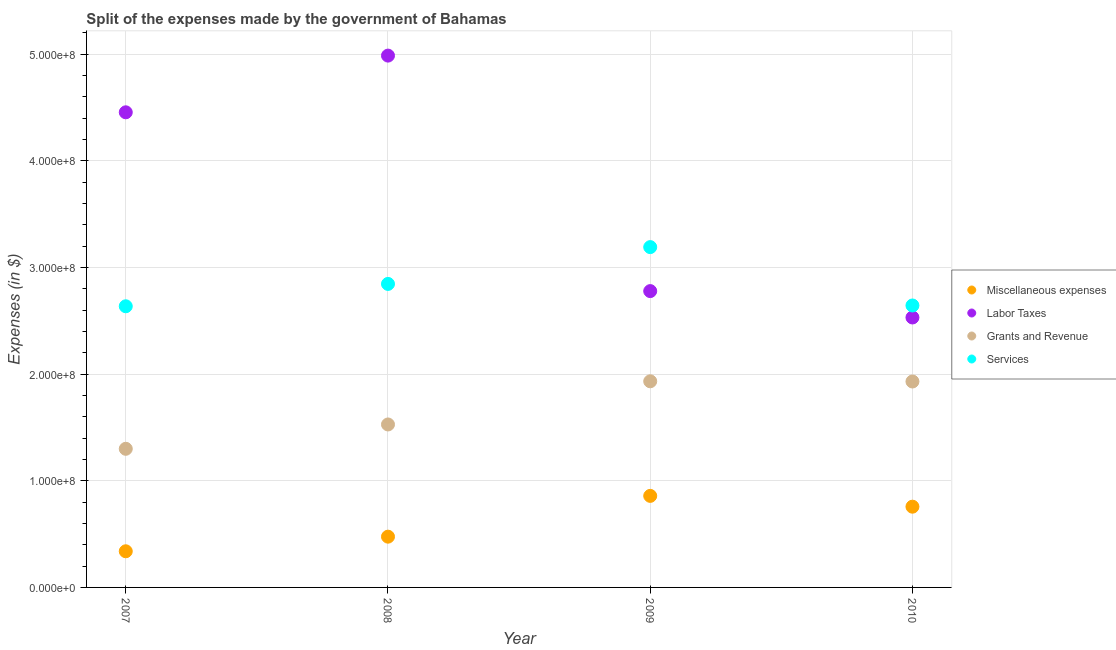What is the amount spent on labor taxes in 2008?
Provide a short and direct response. 4.99e+08. Across all years, what is the maximum amount spent on labor taxes?
Provide a short and direct response. 4.99e+08. Across all years, what is the minimum amount spent on miscellaneous expenses?
Keep it short and to the point. 3.39e+07. What is the total amount spent on grants and revenue in the graph?
Your answer should be compact. 6.69e+08. What is the difference between the amount spent on grants and revenue in 2007 and that in 2008?
Offer a terse response. -2.28e+07. What is the difference between the amount spent on services in 2010 and the amount spent on grants and revenue in 2009?
Keep it short and to the point. 7.11e+07. What is the average amount spent on services per year?
Offer a very short reply. 2.83e+08. In the year 2009, what is the difference between the amount spent on services and amount spent on grants and revenue?
Provide a succinct answer. 1.26e+08. In how many years, is the amount spent on miscellaneous expenses greater than 160000000 $?
Make the answer very short. 0. What is the ratio of the amount spent on labor taxes in 2007 to that in 2009?
Provide a short and direct response. 1.6. Is the amount spent on miscellaneous expenses in 2007 less than that in 2008?
Your answer should be very brief. Yes. Is the difference between the amount spent on services in 2009 and 2010 greater than the difference between the amount spent on miscellaneous expenses in 2009 and 2010?
Ensure brevity in your answer.  Yes. What is the difference between the highest and the second highest amount spent on services?
Provide a succinct answer. 3.45e+07. What is the difference between the highest and the lowest amount spent on services?
Make the answer very short. 5.55e+07. Is the sum of the amount spent on grants and revenue in 2007 and 2009 greater than the maximum amount spent on labor taxes across all years?
Ensure brevity in your answer.  No. Is it the case that in every year, the sum of the amount spent on services and amount spent on miscellaneous expenses is greater than the sum of amount spent on grants and revenue and amount spent on labor taxes?
Your response must be concise. Yes. Is it the case that in every year, the sum of the amount spent on miscellaneous expenses and amount spent on labor taxes is greater than the amount spent on grants and revenue?
Offer a very short reply. Yes. Does the amount spent on labor taxes monotonically increase over the years?
Ensure brevity in your answer.  No. Is the amount spent on services strictly greater than the amount spent on miscellaneous expenses over the years?
Keep it short and to the point. Yes. What is the difference between two consecutive major ticks on the Y-axis?
Make the answer very short. 1.00e+08. Does the graph contain any zero values?
Your response must be concise. No. Where does the legend appear in the graph?
Give a very brief answer. Center right. How are the legend labels stacked?
Your answer should be very brief. Vertical. What is the title of the graph?
Give a very brief answer. Split of the expenses made by the government of Bahamas. Does "Overall level" appear as one of the legend labels in the graph?
Offer a terse response. No. What is the label or title of the X-axis?
Your response must be concise. Year. What is the label or title of the Y-axis?
Provide a short and direct response. Expenses (in $). What is the Expenses (in $) of Miscellaneous expenses in 2007?
Provide a short and direct response. 3.39e+07. What is the Expenses (in $) of Labor Taxes in 2007?
Your answer should be compact. 4.46e+08. What is the Expenses (in $) of Grants and Revenue in 2007?
Give a very brief answer. 1.30e+08. What is the Expenses (in $) in Services in 2007?
Give a very brief answer. 2.64e+08. What is the Expenses (in $) of Miscellaneous expenses in 2008?
Your answer should be compact. 4.76e+07. What is the Expenses (in $) of Labor Taxes in 2008?
Keep it short and to the point. 4.99e+08. What is the Expenses (in $) in Grants and Revenue in 2008?
Your answer should be compact. 1.53e+08. What is the Expenses (in $) of Services in 2008?
Offer a terse response. 2.85e+08. What is the Expenses (in $) in Miscellaneous expenses in 2009?
Provide a short and direct response. 8.58e+07. What is the Expenses (in $) in Labor Taxes in 2009?
Offer a terse response. 2.78e+08. What is the Expenses (in $) in Grants and Revenue in 2009?
Keep it short and to the point. 1.93e+08. What is the Expenses (in $) in Services in 2009?
Ensure brevity in your answer.  3.19e+08. What is the Expenses (in $) of Miscellaneous expenses in 2010?
Make the answer very short. 7.57e+07. What is the Expenses (in $) of Labor Taxes in 2010?
Provide a succinct answer. 2.53e+08. What is the Expenses (in $) in Grants and Revenue in 2010?
Give a very brief answer. 1.93e+08. What is the Expenses (in $) of Services in 2010?
Offer a terse response. 2.64e+08. Across all years, what is the maximum Expenses (in $) in Miscellaneous expenses?
Make the answer very short. 8.58e+07. Across all years, what is the maximum Expenses (in $) in Labor Taxes?
Offer a terse response. 4.99e+08. Across all years, what is the maximum Expenses (in $) of Grants and Revenue?
Your response must be concise. 1.93e+08. Across all years, what is the maximum Expenses (in $) in Services?
Your answer should be very brief. 3.19e+08. Across all years, what is the minimum Expenses (in $) of Miscellaneous expenses?
Offer a terse response. 3.39e+07. Across all years, what is the minimum Expenses (in $) in Labor Taxes?
Provide a succinct answer. 2.53e+08. Across all years, what is the minimum Expenses (in $) of Grants and Revenue?
Keep it short and to the point. 1.30e+08. Across all years, what is the minimum Expenses (in $) of Services?
Keep it short and to the point. 2.64e+08. What is the total Expenses (in $) in Miscellaneous expenses in the graph?
Provide a short and direct response. 2.43e+08. What is the total Expenses (in $) in Labor Taxes in the graph?
Offer a very short reply. 1.48e+09. What is the total Expenses (in $) in Grants and Revenue in the graph?
Provide a succinct answer. 6.69e+08. What is the total Expenses (in $) in Services in the graph?
Your answer should be very brief. 1.13e+09. What is the difference between the Expenses (in $) in Miscellaneous expenses in 2007 and that in 2008?
Give a very brief answer. -1.37e+07. What is the difference between the Expenses (in $) of Labor Taxes in 2007 and that in 2008?
Your answer should be very brief. -5.32e+07. What is the difference between the Expenses (in $) in Grants and Revenue in 2007 and that in 2008?
Your answer should be very brief. -2.28e+07. What is the difference between the Expenses (in $) of Services in 2007 and that in 2008?
Your answer should be very brief. -2.10e+07. What is the difference between the Expenses (in $) in Miscellaneous expenses in 2007 and that in 2009?
Make the answer very short. -5.19e+07. What is the difference between the Expenses (in $) of Labor Taxes in 2007 and that in 2009?
Offer a terse response. 1.68e+08. What is the difference between the Expenses (in $) in Grants and Revenue in 2007 and that in 2009?
Your response must be concise. -6.33e+07. What is the difference between the Expenses (in $) of Services in 2007 and that in 2009?
Provide a succinct answer. -5.55e+07. What is the difference between the Expenses (in $) in Miscellaneous expenses in 2007 and that in 2010?
Offer a terse response. -4.18e+07. What is the difference between the Expenses (in $) in Labor Taxes in 2007 and that in 2010?
Provide a short and direct response. 1.92e+08. What is the difference between the Expenses (in $) in Grants and Revenue in 2007 and that in 2010?
Provide a succinct answer. -6.31e+07. What is the difference between the Expenses (in $) of Services in 2007 and that in 2010?
Ensure brevity in your answer.  -7.35e+05. What is the difference between the Expenses (in $) of Miscellaneous expenses in 2008 and that in 2009?
Make the answer very short. -3.82e+07. What is the difference between the Expenses (in $) in Labor Taxes in 2008 and that in 2009?
Provide a succinct answer. 2.21e+08. What is the difference between the Expenses (in $) in Grants and Revenue in 2008 and that in 2009?
Keep it short and to the point. -4.05e+07. What is the difference between the Expenses (in $) in Services in 2008 and that in 2009?
Offer a very short reply. -3.45e+07. What is the difference between the Expenses (in $) of Miscellaneous expenses in 2008 and that in 2010?
Your answer should be compact. -2.81e+07. What is the difference between the Expenses (in $) in Labor Taxes in 2008 and that in 2010?
Offer a terse response. 2.46e+08. What is the difference between the Expenses (in $) of Grants and Revenue in 2008 and that in 2010?
Provide a short and direct response. -4.03e+07. What is the difference between the Expenses (in $) in Services in 2008 and that in 2010?
Give a very brief answer. 2.02e+07. What is the difference between the Expenses (in $) in Miscellaneous expenses in 2009 and that in 2010?
Provide a short and direct response. 1.01e+07. What is the difference between the Expenses (in $) of Labor Taxes in 2009 and that in 2010?
Offer a very short reply. 2.47e+07. What is the difference between the Expenses (in $) of Grants and Revenue in 2009 and that in 2010?
Offer a very short reply. 1.93e+05. What is the difference between the Expenses (in $) in Services in 2009 and that in 2010?
Your answer should be compact. 5.47e+07. What is the difference between the Expenses (in $) in Miscellaneous expenses in 2007 and the Expenses (in $) in Labor Taxes in 2008?
Offer a very short reply. -4.65e+08. What is the difference between the Expenses (in $) of Miscellaneous expenses in 2007 and the Expenses (in $) of Grants and Revenue in 2008?
Offer a terse response. -1.19e+08. What is the difference between the Expenses (in $) in Miscellaneous expenses in 2007 and the Expenses (in $) in Services in 2008?
Ensure brevity in your answer.  -2.51e+08. What is the difference between the Expenses (in $) in Labor Taxes in 2007 and the Expenses (in $) in Grants and Revenue in 2008?
Your answer should be very brief. 2.93e+08. What is the difference between the Expenses (in $) of Labor Taxes in 2007 and the Expenses (in $) of Services in 2008?
Offer a very short reply. 1.61e+08. What is the difference between the Expenses (in $) in Grants and Revenue in 2007 and the Expenses (in $) in Services in 2008?
Give a very brief answer. -1.55e+08. What is the difference between the Expenses (in $) of Miscellaneous expenses in 2007 and the Expenses (in $) of Labor Taxes in 2009?
Offer a terse response. -2.44e+08. What is the difference between the Expenses (in $) of Miscellaneous expenses in 2007 and the Expenses (in $) of Grants and Revenue in 2009?
Offer a terse response. -1.59e+08. What is the difference between the Expenses (in $) in Miscellaneous expenses in 2007 and the Expenses (in $) in Services in 2009?
Give a very brief answer. -2.85e+08. What is the difference between the Expenses (in $) of Labor Taxes in 2007 and the Expenses (in $) of Grants and Revenue in 2009?
Provide a short and direct response. 2.52e+08. What is the difference between the Expenses (in $) of Labor Taxes in 2007 and the Expenses (in $) of Services in 2009?
Make the answer very short. 1.26e+08. What is the difference between the Expenses (in $) in Grants and Revenue in 2007 and the Expenses (in $) in Services in 2009?
Keep it short and to the point. -1.89e+08. What is the difference between the Expenses (in $) of Miscellaneous expenses in 2007 and the Expenses (in $) of Labor Taxes in 2010?
Provide a short and direct response. -2.19e+08. What is the difference between the Expenses (in $) in Miscellaneous expenses in 2007 and the Expenses (in $) in Grants and Revenue in 2010?
Offer a terse response. -1.59e+08. What is the difference between the Expenses (in $) of Miscellaneous expenses in 2007 and the Expenses (in $) of Services in 2010?
Your response must be concise. -2.30e+08. What is the difference between the Expenses (in $) of Labor Taxes in 2007 and the Expenses (in $) of Grants and Revenue in 2010?
Make the answer very short. 2.52e+08. What is the difference between the Expenses (in $) of Labor Taxes in 2007 and the Expenses (in $) of Services in 2010?
Your answer should be compact. 1.81e+08. What is the difference between the Expenses (in $) in Grants and Revenue in 2007 and the Expenses (in $) in Services in 2010?
Your answer should be compact. -1.34e+08. What is the difference between the Expenses (in $) of Miscellaneous expenses in 2008 and the Expenses (in $) of Labor Taxes in 2009?
Keep it short and to the point. -2.30e+08. What is the difference between the Expenses (in $) of Miscellaneous expenses in 2008 and the Expenses (in $) of Grants and Revenue in 2009?
Make the answer very short. -1.46e+08. What is the difference between the Expenses (in $) of Miscellaneous expenses in 2008 and the Expenses (in $) of Services in 2009?
Keep it short and to the point. -2.72e+08. What is the difference between the Expenses (in $) of Labor Taxes in 2008 and the Expenses (in $) of Grants and Revenue in 2009?
Make the answer very short. 3.05e+08. What is the difference between the Expenses (in $) in Labor Taxes in 2008 and the Expenses (in $) in Services in 2009?
Keep it short and to the point. 1.80e+08. What is the difference between the Expenses (in $) of Grants and Revenue in 2008 and the Expenses (in $) of Services in 2009?
Ensure brevity in your answer.  -1.66e+08. What is the difference between the Expenses (in $) in Miscellaneous expenses in 2008 and the Expenses (in $) in Labor Taxes in 2010?
Provide a short and direct response. -2.06e+08. What is the difference between the Expenses (in $) in Miscellaneous expenses in 2008 and the Expenses (in $) in Grants and Revenue in 2010?
Give a very brief answer. -1.46e+08. What is the difference between the Expenses (in $) in Miscellaneous expenses in 2008 and the Expenses (in $) in Services in 2010?
Give a very brief answer. -2.17e+08. What is the difference between the Expenses (in $) in Labor Taxes in 2008 and the Expenses (in $) in Grants and Revenue in 2010?
Your answer should be very brief. 3.06e+08. What is the difference between the Expenses (in $) in Labor Taxes in 2008 and the Expenses (in $) in Services in 2010?
Your answer should be compact. 2.34e+08. What is the difference between the Expenses (in $) in Grants and Revenue in 2008 and the Expenses (in $) in Services in 2010?
Make the answer very short. -1.12e+08. What is the difference between the Expenses (in $) of Miscellaneous expenses in 2009 and the Expenses (in $) of Labor Taxes in 2010?
Keep it short and to the point. -1.67e+08. What is the difference between the Expenses (in $) in Miscellaneous expenses in 2009 and the Expenses (in $) in Grants and Revenue in 2010?
Give a very brief answer. -1.07e+08. What is the difference between the Expenses (in $) in Miscellaneous expenses in 2009 and the Expenses (in $) in Services in 2010?
Give a very brief answer. -1.79e+08. What is the difference between the Expenses (in $) of Labor Taxes in 2009 and the Expenses (in $) of Grants and Revenue in 2010?
Make the answer very short. 8.48e+07. What is the difference between the Expenses (in $) in Labor Taxes in 2009 and the Expenses (in $) in Services in 2010?
Your answer should be compact. 1.35e+07. What is the difference between the Expenses (in $) in Grants and Revenue in 2009 and the Expenses (in $) in Services in 2010?
Your answer should be very brief. -7.11e+07. What is the average Expenses (in $) in Miscellaneous expenses per year?
Your answer should be compact. 6.08e+07. What is the average Expenses (in $) of Labor Taxes per year?
Provide a short and direct response. 3.69e+08. What is the average Expenses (in $) in Grants and Revenue per year?
Keep it short and to the point. 1.67e+08. What is the average Expenses (in $) of Services per year?
Provide a succinct answer. 2.83e+08. In the year 2007, what is the difference between the Expenses (in $) of Miscellaneous expenses and Expenses (in $) of Labor Taxes?
Provide a short and direct response. -4.12e+08. In the year 2007, what is the difference between the Expenses (in $) in Miscellaneous expenses and Expenses (in $) in Grants and Revenue?
Make the answer very short. -9.61e+07. In the year 2007, what is the difference between the Expenses (in $) in Miscellaneous expenses and Expenses (in $) in Services?
Your answer should be very brief. -2.30e+08. In the year 2007, what is the difference between the Expenses (in $) in Labor Taxes and Expenses (in $) in Grants and Revenue?
Your answer should be very brief. 3.16e+08. In the year 2007, what is the difference between the Expenses (in $) of Labor Taxes and Expenses (in $) of Services?
Offer a very short reply. 1.82e+08. In the year 2007, what is the difference between the Expenses (in $) in Grants and Revenue and Expenses (in $) in Services?
Provide a succinct answer. -1.34e+08. In the year 2008, what is the difference between the Expenses (in $) in Miscellaneous expenses and Expenses (in $) in Labor Taxes?
Your answer should be compact. -4.51e+08. In the year 2008, what is the difference between the Expenses (in $) of Miscellaneous expenses and Expenses (in $) of Grants and Revenue?
Give a very brief answer. -1.05e+08. In the year 2008, what is the difference between the Expenses (in $) in Miscellaneous expenses and Expenses (in $) in Services?
Make the answer very short. -2.37e+08. In the year 2008, what is the difference between the Expenses (in $) in Labor Taxes and Expenses (in $) in Grants and Revenue?
Provide a short and direct response. 3.46e+08. In the year 2008, what is the difference between the Expenses (in $) of Labor Taxes and Expenses (in $) of Services?
Your response must be concise. 2.14e+08. In the year 2008, what is the difference between the Expenses (in $) in Grants and Revenue and Expenses (in $) in Services?
Make the answer very short. -1.32e+08. In the year 2009, what is the difference between the Expenses (in $) of Miscellaneous expenses and Expenses (in $) of Labor Taxes?
Keep it short and to the point. -1.92e+08. In the year 2009, what is the difference between the Expenses (in $) of Miscellaneous expenses and Expenses (in $) of Grants and Revenue?
Make the answer very short. -1.07e+08. In the year 2009, what is the difference between the Expenses (in $) in Miscellaneous expenses and Expenses (in $) in Services?
Give a very brief answer. -2.33e+08. In the year 2009, what is the difference between the Expenses (in $) in Labor Taxes and Expenses (in $) in Grants and Revenue?
Give a very brief answer. 8.46e+07. In the year 2009, what is the difference between the Expenses (in $) in Labor Taxes and Expenses (in $) in Services?
Provide a succinct answer. -4.12e+07. In the year 2009, what is the difference between the Expenses (in $) in Grants and Revenue and Expenses (in $) in Services?
Your response must be concise. -1.26e+08. In the year 2010, what is the difference between the Expenses (in $) of Miscellaneous expenses and Expenses (in $) of Labor Taxes?
Make the answer very short. -1.77e+08. In the year 2010, what is the difference between the Expenses (in $) in Miscellaneous expenses and Expenses (in $) in Grants and Revenue?
Provide a succinct answer. -1.17e+08. In the year 2010, what is the difference between the Expenses (in $) in Miscellaneous expenses and Expenses (in $) in Services?
Your answer should be compact. -1.89e+08. In the year 2010, what is the difference between the Expenses (in $) of Labor Taxes and Expenses (in $) of Grants and Revenue?
Provide a succinct answer. 6.00e+07. In the year 2010, what is the difference between the Expenses (in $) in Labor Taxes and Expenses (in $) in Services?
Provide a succinct answer. -1.12e+07. In the year 2010, what is the difference between the Expenses (in $) of Grants and Revenue and Expenses (in $) of Services?
Provide a succinct answer. -7.13e+07. What is the ratio of the Expenses (in $) in Miscellaneous expenses in 2007 to that in 2008?
Offer a terse response. 0.71. What is the ratio of the Expenses (in $) of Labor Taxes in 2007 to that in 2008?
Give a very brief answer. 0.89. What is the ratio of the Expenses (in $) in Grants and Revenue in 2007 to that in 2008?
Your response must be concise. 0.85. What is the ratio of the Expenses (in $) of Services in 2007 to that in 2008?
Your answer should be compact. 0.93. What is the ratio of the Expenses (in $) in Miscellaneous expenses in 2007 to that in 2009?
Offer a very short reply. 0.39. What is the ratio of the Expenses (in $) of Labor Taxes in 2007 to that in 2009?
Keep it short and to the point. 1.6. What is the ratio of the Expenses (in $) of Grants and Revenue in 2007 to that in 2009?
Ensure brevity in your answer.  0.67. What is the ratio of the Expenses (in $) in Services in 2007 to that in 2009?
Your answer should be very brief. 0.83. What is the ratio of the Expenses (in $) of Miscellaneous expenses in 2007 to that in 2010?
Make the answer very short. 0.45. What is the ratio of the Expenses (in $) of Labor Taxes in 2007 to that in 2010?
Give a very brief answer. 1.76. What is the ratio of the Expenses (in $) in Grants and Revenue in 2007 to that in 2010?
Provide a short and direct response. 0.67. What is the ratio of the Expenses (in $) in Miscellaneous expenses in 2008 to that in 2009?
Keep it short and to the point. 0.55. What is the ratio of the Expenses (in $) of Labor Taxes in 2008 to that in 2009?
Provide a succinct answer. 1.79. What is the ratio of the Expenses (in $) in Grants and Revenue in 2008 to that in 2009?
Your answer should be compact. 0.79. What is the ratio of the Expenses (in $) of Services in 2008 to that in 2009?
Ensure brevity in your answer.  0.89. What is the ratio of the Expenses (in $) in Miscellaneous expenses in 2008 to that in 2010?
Your answer should be compact. 0.63. What is the ratio of the Expenses (in $) in Labor Taxes in 2008 to that in 2010?
Your response must be concise. 1.97. What is the ratio of the Expenses (in $) in Grants and Revenue in 2008 to that in 2010?
Provide a short and direct response. 0.79. What is the ratio of the Expenses (in $) in Services in 2008 to that in 2010?
Offer a terse response. 1.08. What is the ratio of the Expenses (in $) in Miscellaneous expenses in 2009 to that in 2010?
Provide a short and direct response. 1.13. What is the ratio of the Expenses (in $) in Labor Taxes in 2009 to that in 2010?
Offer a very short reply. 1.1. What is the ratio of the Expenses (in $) in Services in 2009 to that in 2010?
Make the answer very short. 1.21. What is the difference between the highest and the second highest Expenses (in $) of Miscellaneous expenses?
Keep it short and to the point. 1.01e+07. What is the difference between the highest and the second highest Expenses (in $) in Labor Taxes?
Offer a terse response. 5.32e+07. What is the difference between the highest and the second highest Expenses (in $) in Grants and Revenue?
Your answer should be very brief. 1.93e+05. What is the difference between the highest and the second highest Expenses (in $) of Services?
Your response must be concise. 3.45e+07. What is the difference between the highest and the lowest Expenses (in $) in Miscellaneous expenses?
Offer a terse response. 5.19e+07. What is the difference between the highest and the lowest Expenses (in $) of Labor Taxes?
Your answer should be compact. 2.46e+08. What is the difference between the highest and the lowest Expenses (in $) of Grants and Revenue?
Provide a short and direct response. 6.33e+07. What is the difference between the highest and the lowest Expenses (in $) in Services?
Keep it short and to the point. 5.55e+07. 